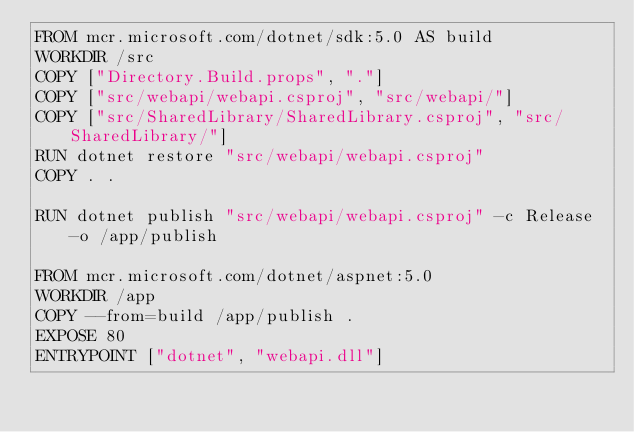<code> <loc_0><loc_0><loc_500><loc_500><_Dockerfile_>FROM mcr.microsoft.com/dotnet/sdk:5.0 AS build
WORKDIR /src
COPY ["Directory.Build.props", "."]
COPY ["src/webapi/webapi.csproj", "src/webapi/"]
COPY ["src/SharedLibrary/SharedLibrary.csproj", "src/SharedLibrary/"]
RUN dotnet restore "src/webapi/webapi.csproj"
COPY . .

RUN dotnet publish "src/webapi/webapi.csproj" -c Release -o /app/publish

FROM mcr.microsoft.com/dotnet/aspnet:5.0
WORKDIR /app
COPY --from=build /app/publish .
EXPOSE 80
ENTRYPOINT ["dotnet", "webapi.dll"]</code> 